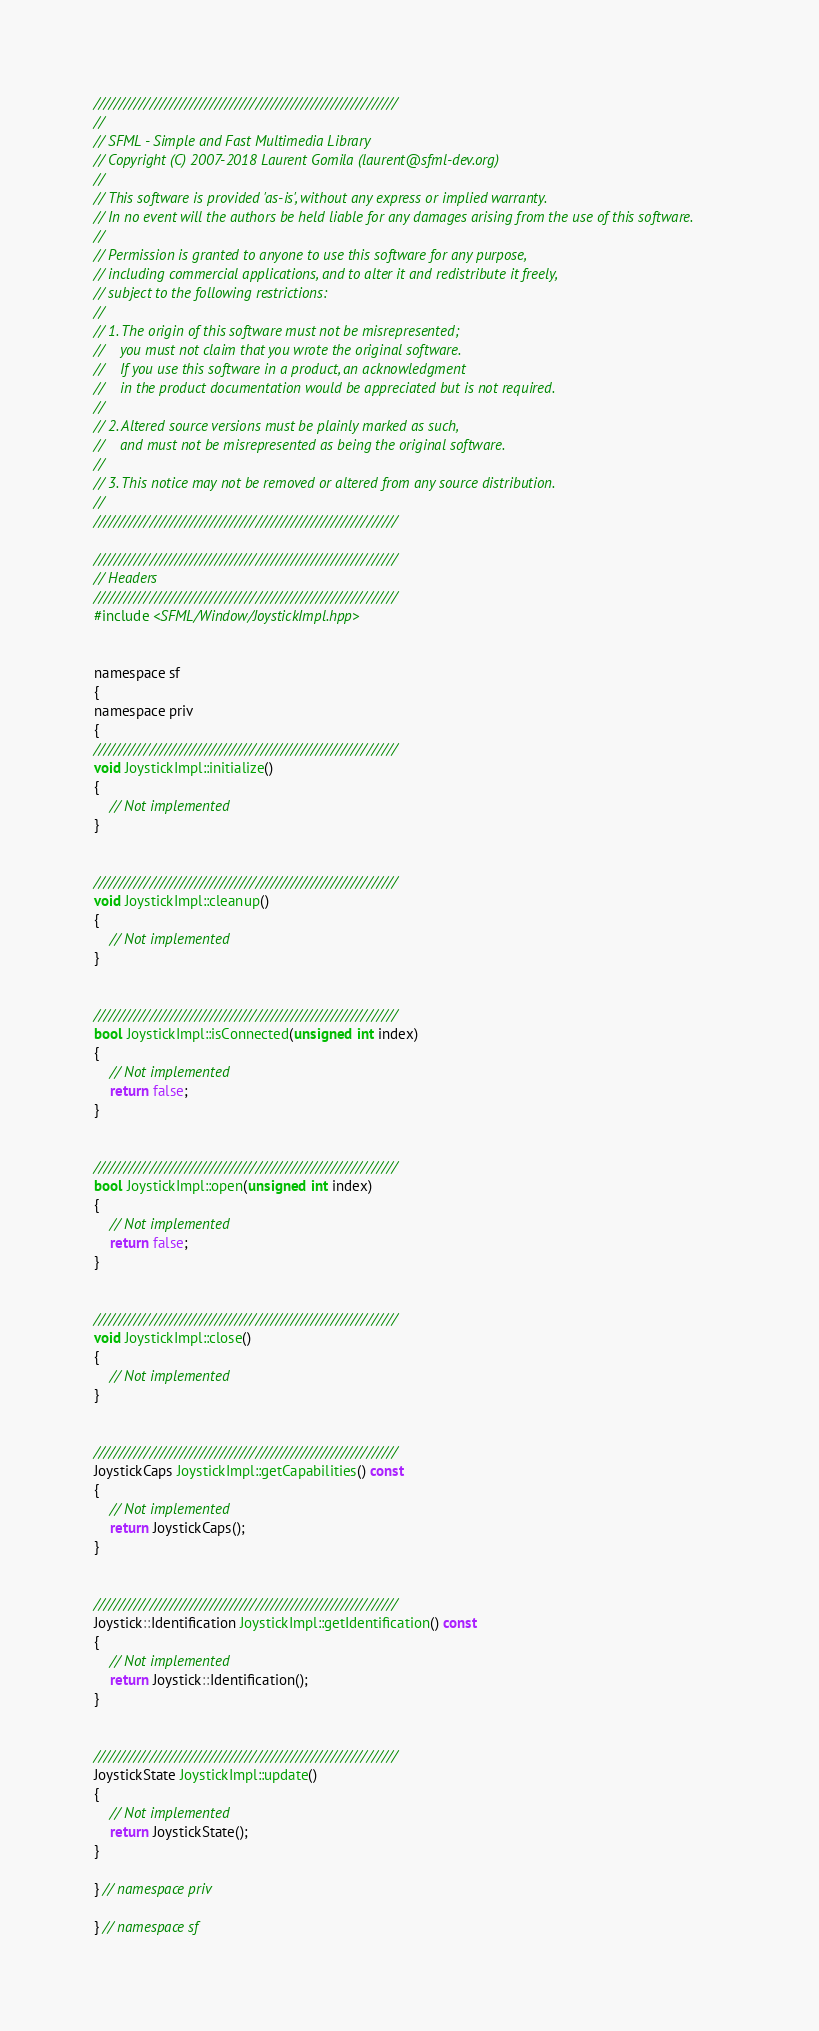<code> <loc_0><loc_0><loc_500><loc_500><_ObjectiveC_>////////////////////////////////////////////////////////////
//
// SFML - Simple and Fast Multimedia Library
// Copyright (C) 2007-2018 Laurent Gomila (laurent@sfml-dev.org)
//
// This software is provided 'as-is', without any express or implied warranty.
// In no event will the authors be held liable for any damages arising from the use of this software.
//
// Permission is granted to anyone to use this software for any purpose,
// including commercial applications, and to alter it and redistribute it freely,
// subject to the following restrictions:
//
// 1. The origin of this software must not be misrepresented;
//    you must not claim that you wrote the original software.
//    If you use this software in a product, an acknowledgment
//    in the product documentation would be appreciated but is not required.
//
// 2. Altered source versions must be plainly marked as such,
//    and must not be misrepresented as being the original software.
//
// 3. This notice may not be removed or altered from any source distribution.
//
////////////////////////////////////////////////////////////

////////////////////////////////////////////////////////////
// Headers
////////////////////////////////////////////////////////////
#include <SFML/Window/JoystickImpl.hpp>


namespace sf
{
namespace priv
{
////////////////////////////////////////////////////////////
void JoystickImpl::initialize()
{
    // Not implemented
}


////////////////////////////////////////////////////////////
void JoystickImpl::cleanup()
{
    // Not implemented
}


////////////////////////////////////////////////////////////
bool JoystickImpl::isConnected(unsigned int index)
{
    // Not implemented
    return false;
}


////////////////////////////////////////////////////////////
bool JoystickImpl::open(unsigned int index)
{
    // Not implemented
    return false;
}


////////////////////////////////////////////////////////////
void JoystickImpl::close()
{
    // Not implemented
}


////////////////////////////////////////////////////////////
JoystickCaps JoystickImpl::getCapabilities() const
{
    // Not implemented
    return JoystickCaps();
}


////////////////////////////////////////////////////////////
Joystick::Identification JoystickImpl::getIdentification() const
{
    // Not implemented
    return Joystick::Identification();
}


////////////////////////////////////////////////////////////
JoystickState JoystickImpl::update()
{
    // Not implemented
    return JoystickState();
}

} // namespace priv

} // namespace sf
</code> 